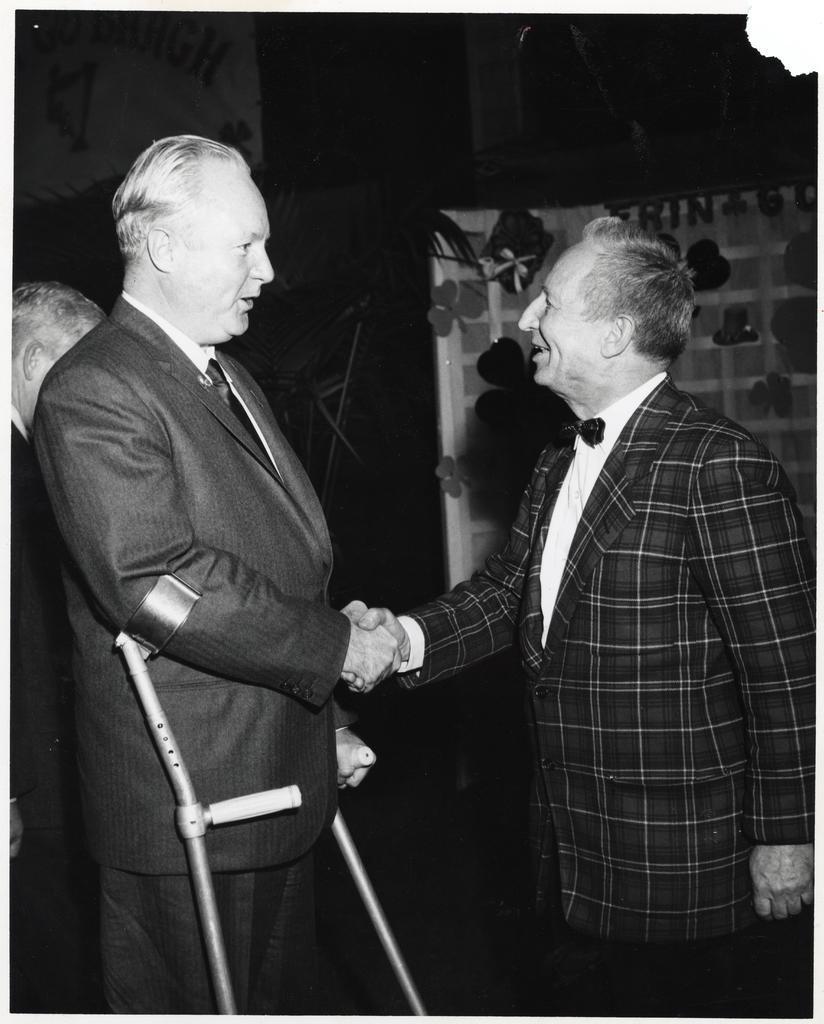Please provide a concise description of this image. In the picture we can see two men are wearing a blazer and shaking hands with each other in the background, we can see a curtain and a person standing. 